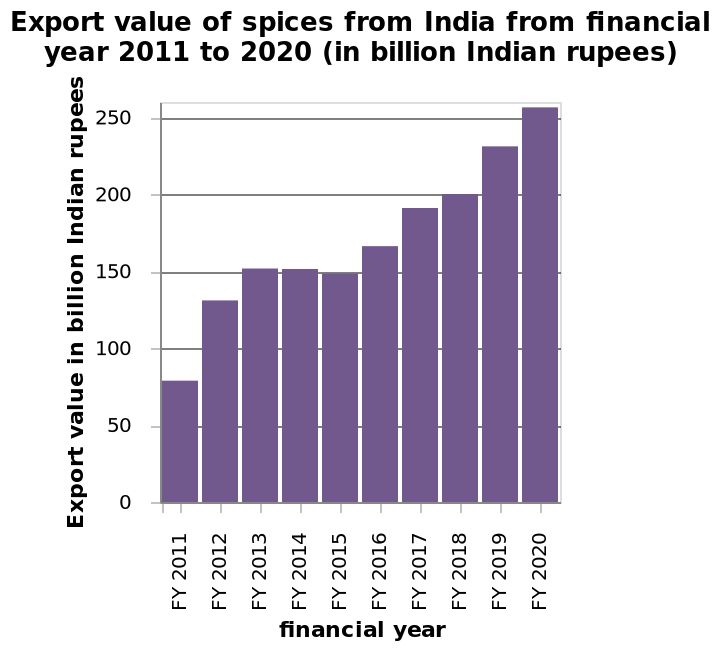<image>
Was there any period of stagnation in the export value of spices from India? Yes, there was a stagnating period between 2013 and 2015. How was the increase in export value of spices from India distributed over the years? The increase in export value of spices from India was quite uniformly spread over the years, except for the period between 2013 and 2015. What is the total export value of spices from India in FY 2020? The total export value of spices from India in FY 2020 is not mentioned in the description. Did the export value of spices increase or decrease between 2011 and 2020? The export value of spices from India increased dramatically between 2011 and 2020. What is the highest export value of spices during the given period? The highest export value of spices from India during the given period is not provided in the description. Was there a progressing period between 2013 and 2015? No.Yes, there was a stagnating period between 2013 and 2015. 